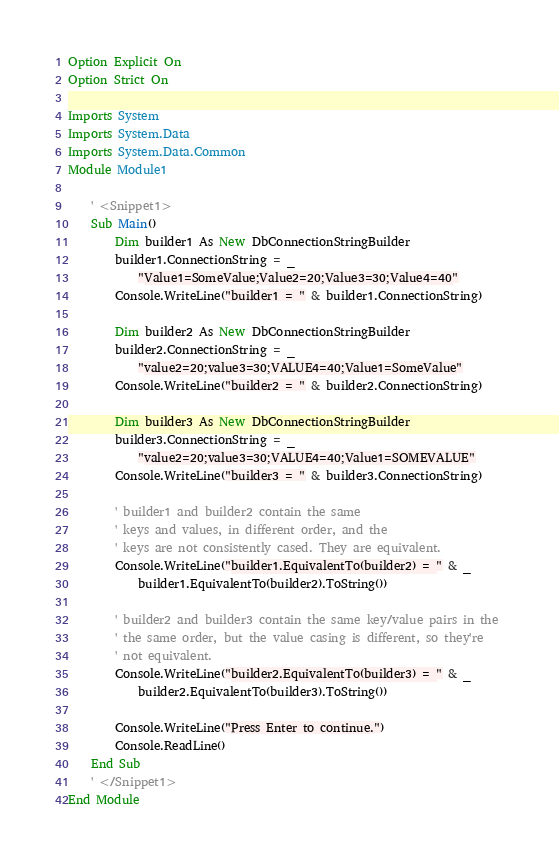Convert code to text. <code><loc_0><loc_0><loc_500><loc_500><_VisualBasic_>Option Explicit On
Option Strict On

Imports System
Imports System.Data
Imports System.Data.Common
Module Module1

    ' <Snippet1>
    Sub Main()
        Dim builder1 As New DbConnectionStringBuilder
        builder1.ConnectionString = _
            "Value1=SomeValue;Value2=20;Value3=30;Value4=40"
        Console.WriteLine("builder1 = " & builder1.ConnectionString)

        Dim builder2 As New DbConnectionStringBuilder
        builder2.ConnectionString = _
            "value2=20;value3=30;VALUE4=40;Value1=SomeValue"
        Console.WriteLine("builder2 = " & builder2.ConnectionString)

        Dim builder3 As New DbConnectionStringBuilder
        builder3.ConnectionString = _
            "value2=20;value3=30;VALUE4=40;Value1=SOMEVALUE"
        Console.WriteLine("builder3 = " & builder3.ConnectionString)

        ' builder1 and builder2 contain the same
        ' keys and values, in different order, and the 
        ' keys are not consistently cased. They are equivalent.
        Console.WriteLine("builder1.EquivalentTo(builder2) = " & _
            builder1.EquivalentTo(builder2).ToString())

        ' builder2 and builder3 contain the same key/value pairs in the 
        ' the same order, but the value casing is different, so they're
        ' not equivalent.
        Console.WriteLine("builder2.EquivalentTo(builder3) = " & _
            builder2.EquivalentTo(builder3).ToString())

        Console.WriteLine("Press Enter to continue.")
        Console.ReadLine()
    End Sub
    ' </Snippet1>
End Module
</code> 